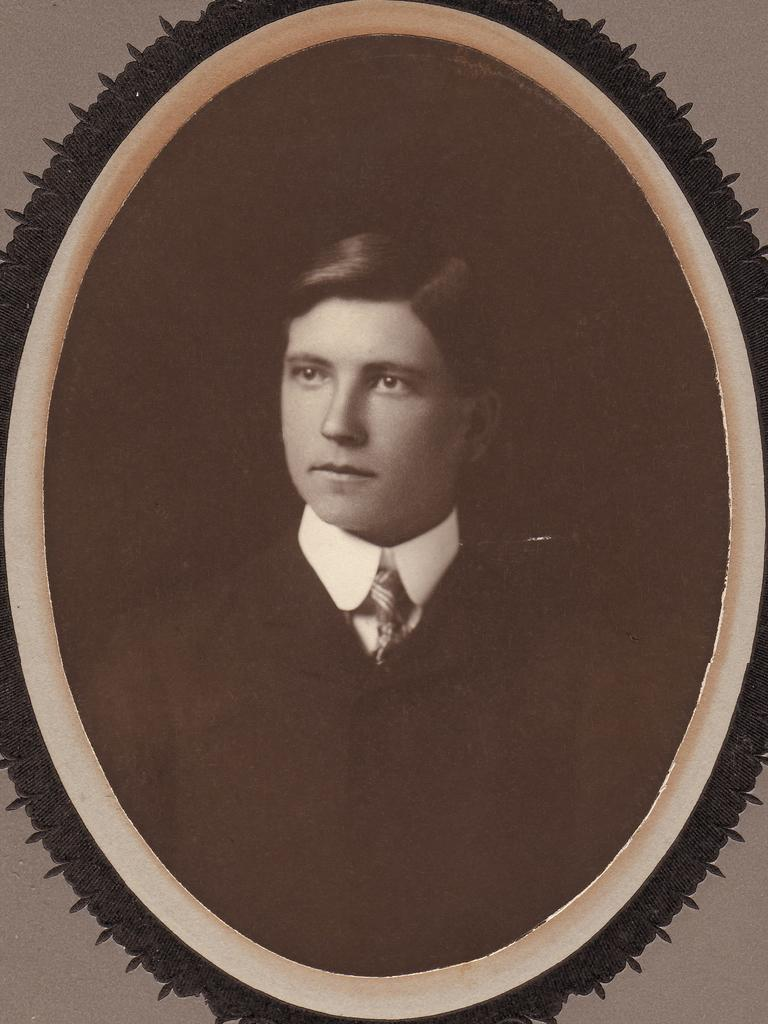What is the main object in the center of the image? There is a photo frame in the center of the image. What is displayed within the photo frame? The photo frame contains a picture of a person. What can be seen behind the photo frame? There is a wall in the background of the image. What type of plastic material can be seen bursting near the sea in the image? There is no plastic material or sea present in the image; it only features a photo frame with a picture of a person and a wall in the background. 